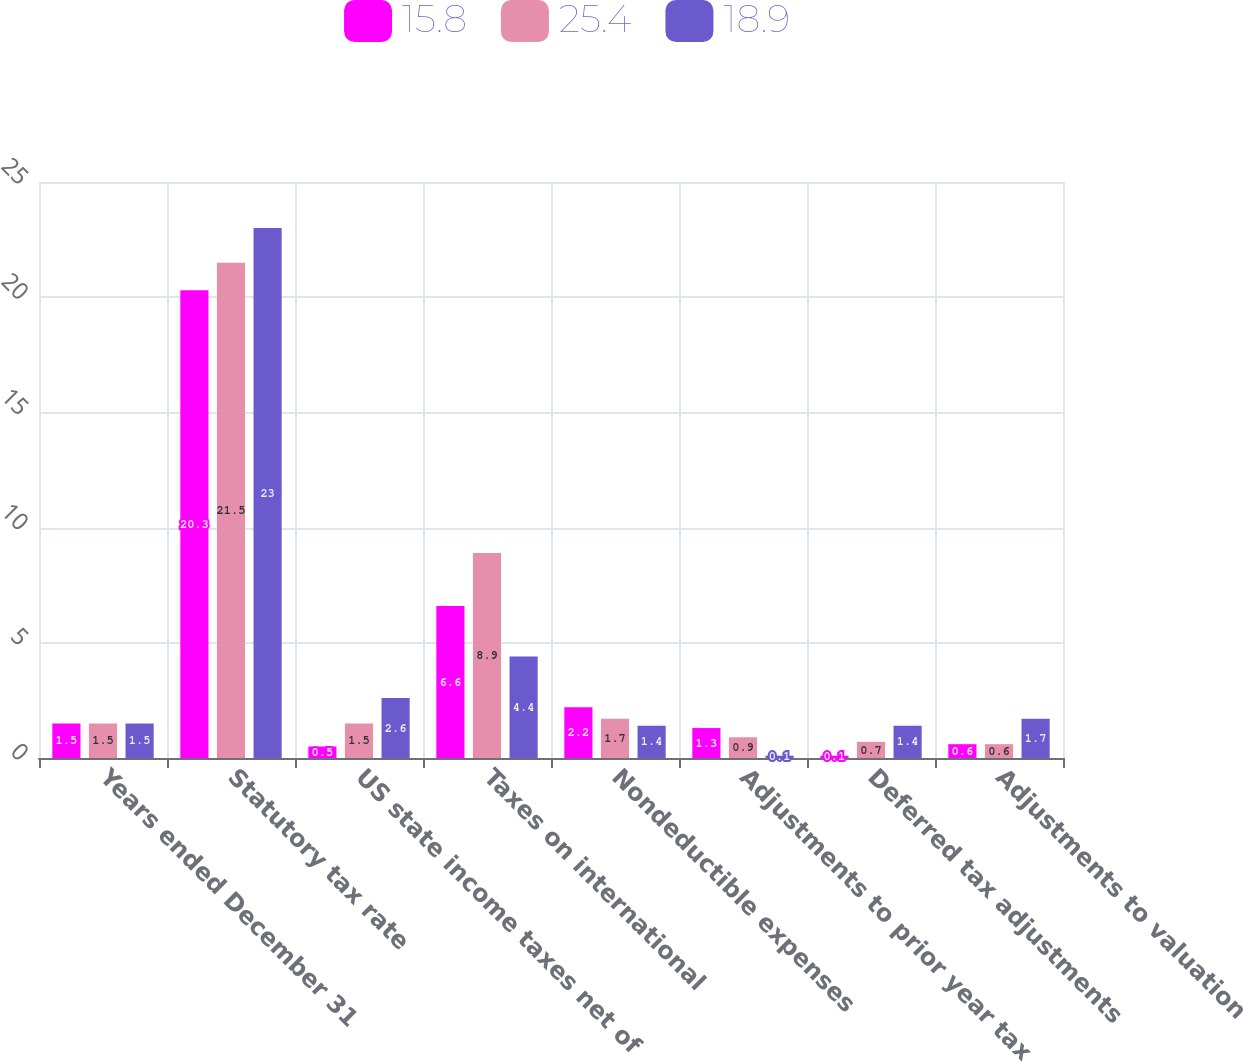Convert chart. <chart><loc_0><loc_0><loc_500><loc_500><stacked_bar_chart><ecel><fcel>Years ended December 31<fcel>Statutory tax rate<fcel>US state income taxes net of<fcel>Taxes on international<fcel>Nondeductible expenses<fcel>Adjustments to prior year tax<fcel>Deferred tax adjustments<fcel>Adjustments to valuation<nl><fcel>15.8<fcel>1.5<fcel>20.3<fcel>0.5<fcel>6.6<fcel>2.2<fcel>1.3<fcel>0.1<fcel>0.6<nl><fcel>25.4<fcel>1.5<fcel>21.5<fcel>1.5<fcel>8.9<fcel>1.7<fcel>0.9<fcel>0.7<fcel>0.6<nl><fcel>18.9<fcel>1.5<fcel>23<fcel>2.6<fcel>4.4<fcel>1.4<fcel>0.1<fcel>1.4<fcel>1.7<nl></chart> 